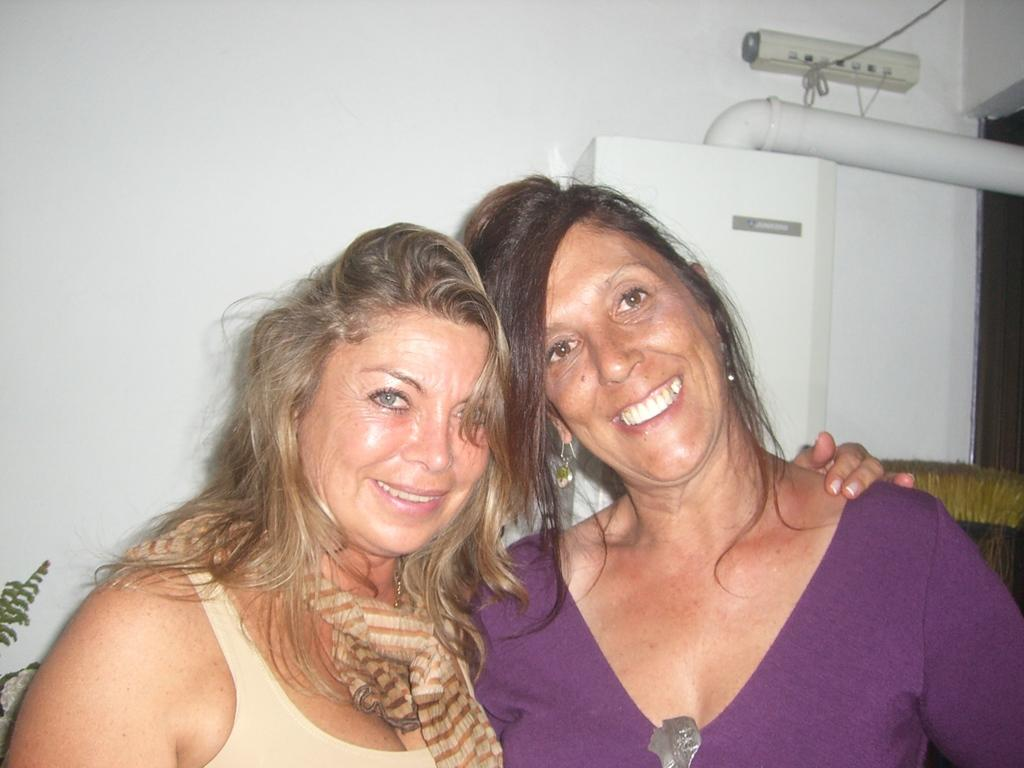Who is present in the image? There is a woman in the image. What is the woman doing in the image? The woman is standing and smiling. What can be seen in the background of the image? There is a wall in the background of the image. What object can be seen in the image besides the woman? There is a pipe in the image. What type of frame is the woman holding in the image? There is no frame present in the image; the woman is simply standing and smiling. 